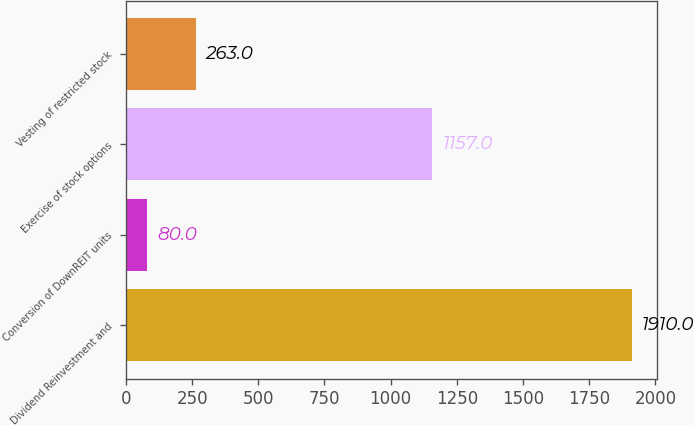Convert chart to OTSL. <chart><loc_0><loc_0><loc_500><loc_500><bar_chart><fcel>Dividend Reinvestment and<fcel>Conversion of DownREIT units<fcel>Exercise of stock options<fcel>Vesting of restricted stock<nl><fcel>1910<fcel>80<fcel>1157<fcel>263<nl></chart> 